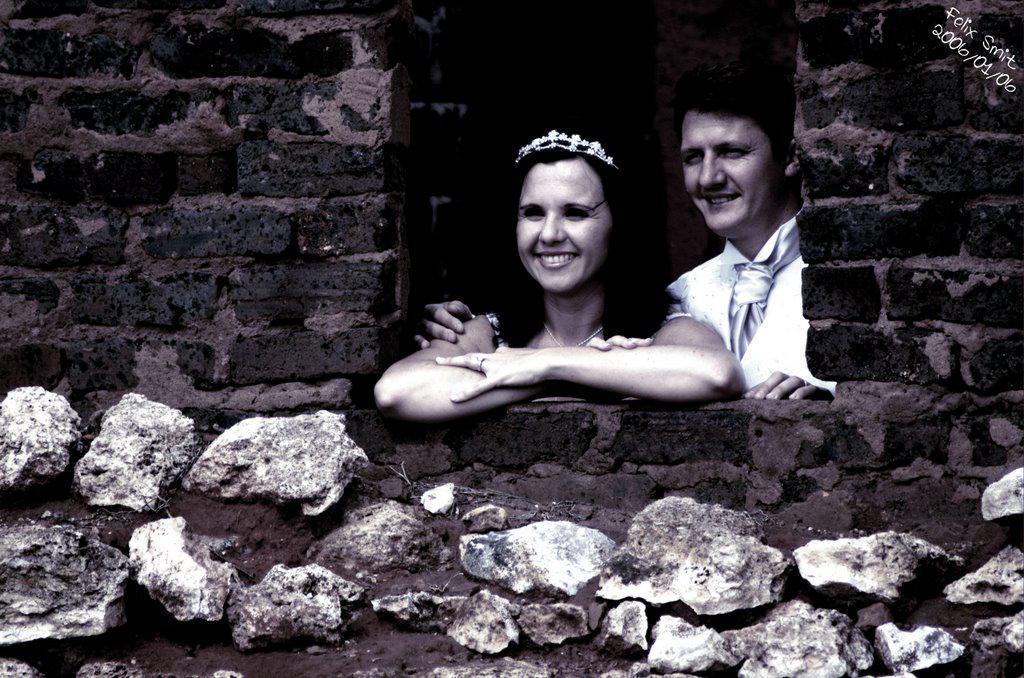How would you summarize this image in a sentence or two? In this image there are two people standing inside the building and having a smile on their faces. There is some text and a date on the top right of the image. 